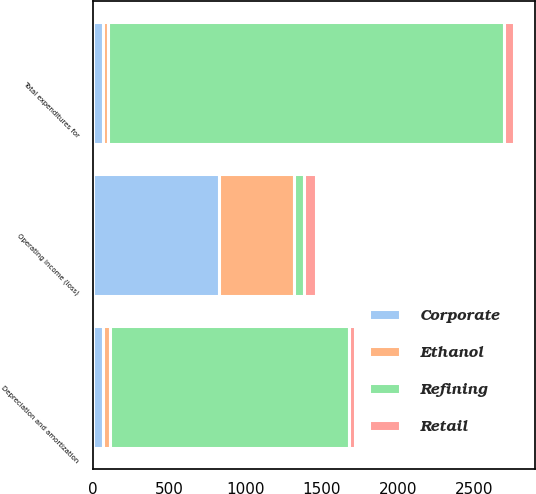Convert chart. <chart><loc_0><loc_0><loc_500><loc_500><stacked_bar_chart><ecel><fcel>Depreciation and amortization<fcel>Operating income (loss)<fcel>Total expenditures for<nl><fcel>Refining<fcel>1566<fcel>68<fcel>2597<nl><fcel>Retail<fcel>41<fcel>81<fcel>62<nl><fcel>Ethanol<fcel>45<fcel>491<fcel>33<nl><fcel>Corporate<fcel>68<fcel>826<fcel>65<nl></chart> 